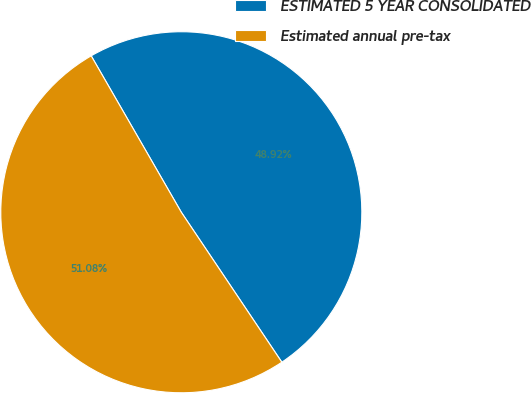<chart> <loc_0><loc_0><loc_500><loc_500><pie_chart><fcel>ESTIMATED 5 YEAR CONSOLIDATED<fcel>Estimated annual pre-tax<nl><fcel>48.92%<fcel>51.08%<nl></chart> 